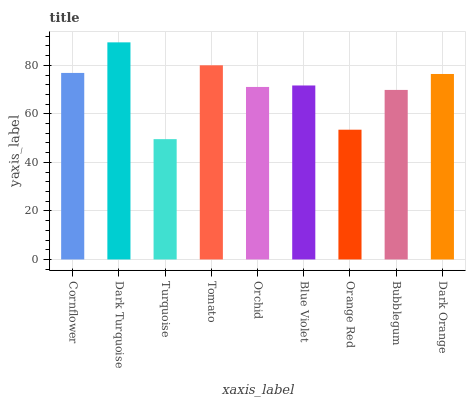Is Turquoise the minimum?
Answer yes or no. Yes. Is Dark Turquoise the maximum?
Answer yes or no. Yes. Is Dark Turquoise the minimum?
Answer yes or no. No. Is Turquoise the maximum?
Answer yes or no. No. Is Dark Turquoise greater than Turquoise?
Answer yes or no. Yes. Is Turquoise less than Dark Turquoise?
Answer yes or no. Yes. Is Turquoise greater than Dark Turquoise?
Answer yes or no. No. Is Dark Turquoise less than Turquoise?
Answer yes or no. No. Is Blue Violet the high median?
Answer yes or no. Yes. Is Blue Violet the low median?
Answer yes or no. Yes. Is Orchid the high median?
Answer yes or no. No. Is Dark Turquoise the low median?
Answer yes or no. No. 